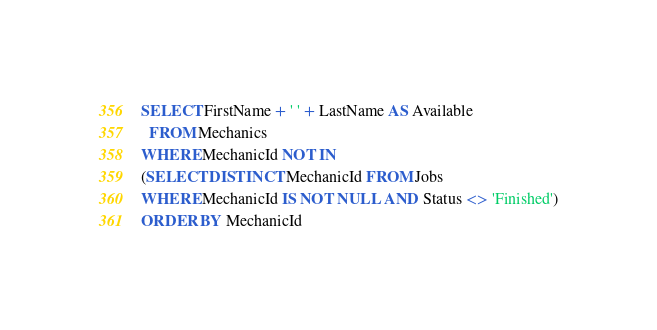<code> <loc_0><loc_0><loc_500><loc_500><_SQL_>SELECT FirstName + ' ' + LastName AS Available
  FROM Mechanics
WHERE MechanicId NOT IN
(SELECT DISTINCT MechanicId FROM Jobs
WHERE MechanicId IS NOT NULL AND Status <> 'Finished')
ORDER BY MechanicId</code> 